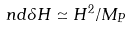Convert formula to latex. <formula><loc_0><loc_0><loc_500><loc_500>\ n d { \delta H } \simeq H ^ { 2 } / M _ { P }</formula> 